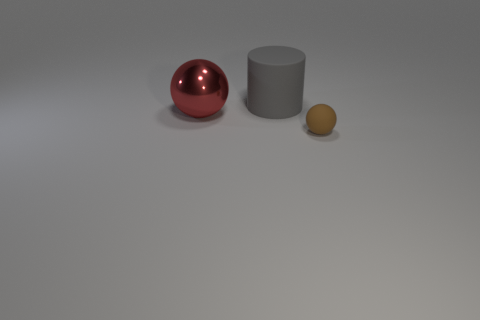Add 1 matte things. How many objects exist? 4 Subtract all cylinders. How many objects are left? 2 Subtract all metallic things. Subtract all big red rubber blocks. How many objects are left? 2 Add 3 gray matte things. How many gray matte things are left? 4 Add 2 big purple balls. How many big purple balls exist? 2 Subtract 0 purple blocks. How many objects are left? 3 